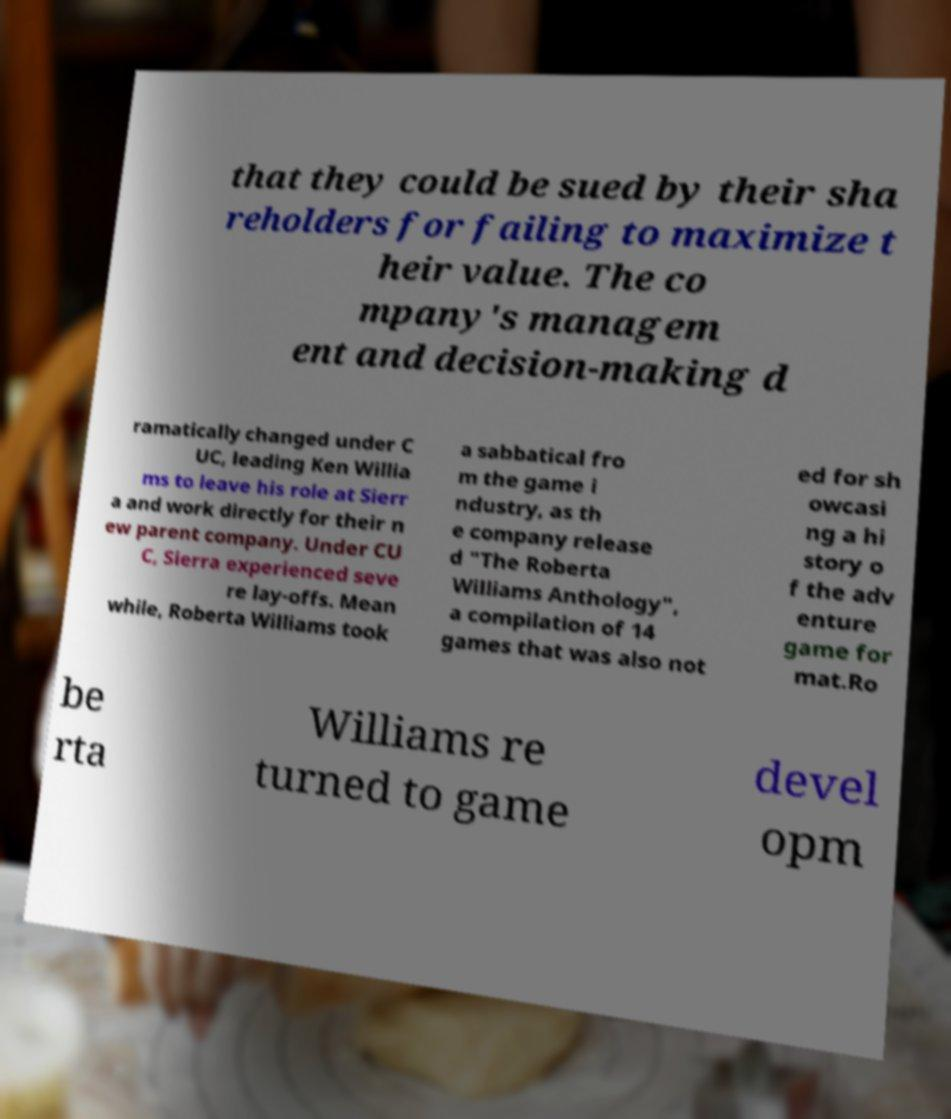Please identify and transcribe the text found in this image. that they could be sued by their sha reholders for failing to maximize t heir value. The co mpany's managem ent and decision-making d ramatically changed under C UC, leading Ken Willia ms to leave his role at Sierr a and work directly for their n ew parent company. Under CU C, Sierra experienced seve re lay-offs. Mean while, Roberta Williams took a sabbatical fro m the game i ndustry, as th e company release d "The Roberta Williams Anthology", a compilation of 14 games that was also not ed for sh owcasi ng a hi story o f the adv enture game for mat.Ro be rta Williams re turned to game devel opm 